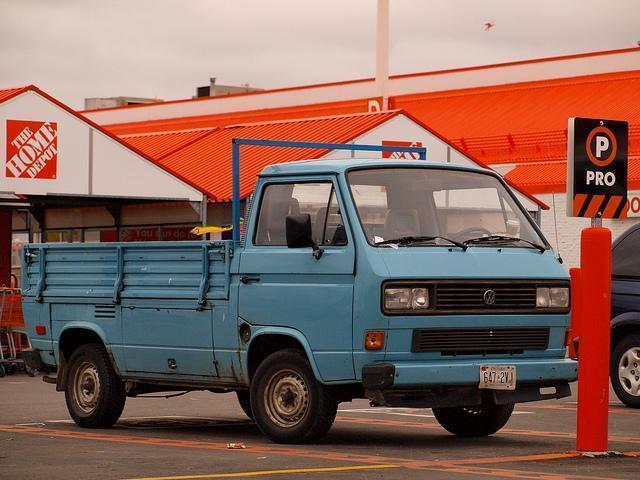What does the store to the left sell?
From the following four choices, select the correct answer to address the question.
Options: Hammers, donuts, sandwiches, pizza. Hammers. 